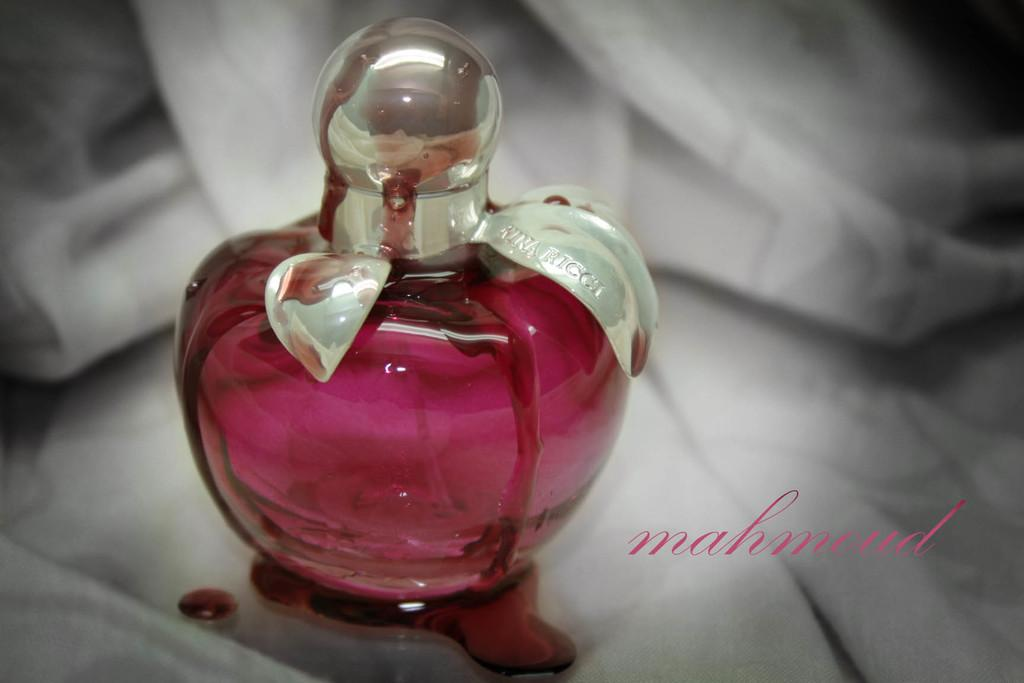<image>
Render a clear and concise summary of the photo. The ad showcases a burgundy perfume bottle for sale. 